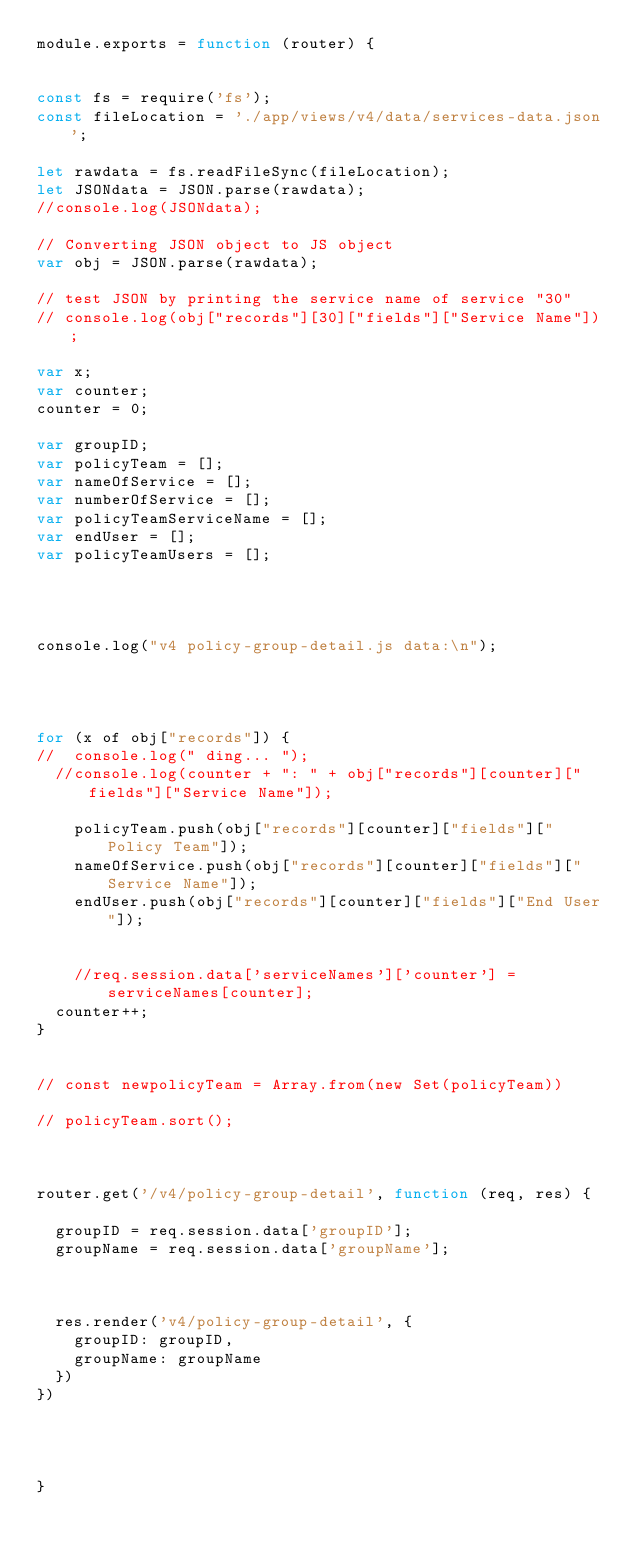Convert code to text. <code><loc_0><loc_0><loc_500><loc_500><_JavaScript_>module.exports = function (router) {


const fs = require('fs');
const fileLocation = './app/views/v4/data/services-data.json';

let rawdata = fs.readFileSync(fileLocation);
let JSONdata = JSON.parse(rawdata);
//console.log(JSONdata);

// Converting JSON object to JS object
var obj = JSON.parse(rawdata);

// test JSON by printing the service name of service "30"
// console.log(obj["records"][30]["fields"]["Service Name"]);

var x;
var counter;
counter = 0;

var groupID;
var policyTeam = [];
var nameOfService = [];
var numberOfService = [];
var policyTeamServiceName = [];
var endUser = [];
var policyTeamUsers = [];




console.log("v4 policy-group-detail.js data:\n");




for (x of obj["records"]) {
//  console.log(" ding... ");
  //console.log(counter + ": " + obj["records"][counter]["fields"]["Service Name"]);

    policyTeam.push(obj["records"][counter]["fields"]["Policy Team"]);
    nameOfService.push(obj["records"][counter]["fields"]["Service Name"]);
    endUser.push(obj["records"][counter]["fields"]["End User"]);


    //req.session.data['serviceNames']['counter'] = serviceNames[counter];
  counter++;
}


// const newpolicyTeam = Array.from(new Set(policyTeam))

// policyTeam.sort();



router.get('/v4/policy-group-detail', function (req, res) {

  groupID = req.session.data['groupID'];
  groupName = req.session.data['groupName'];



  res.render('v4/policy-group-detail', {
    groupID: groupID,
    groupName: groupName
  })
})




}
</code> 